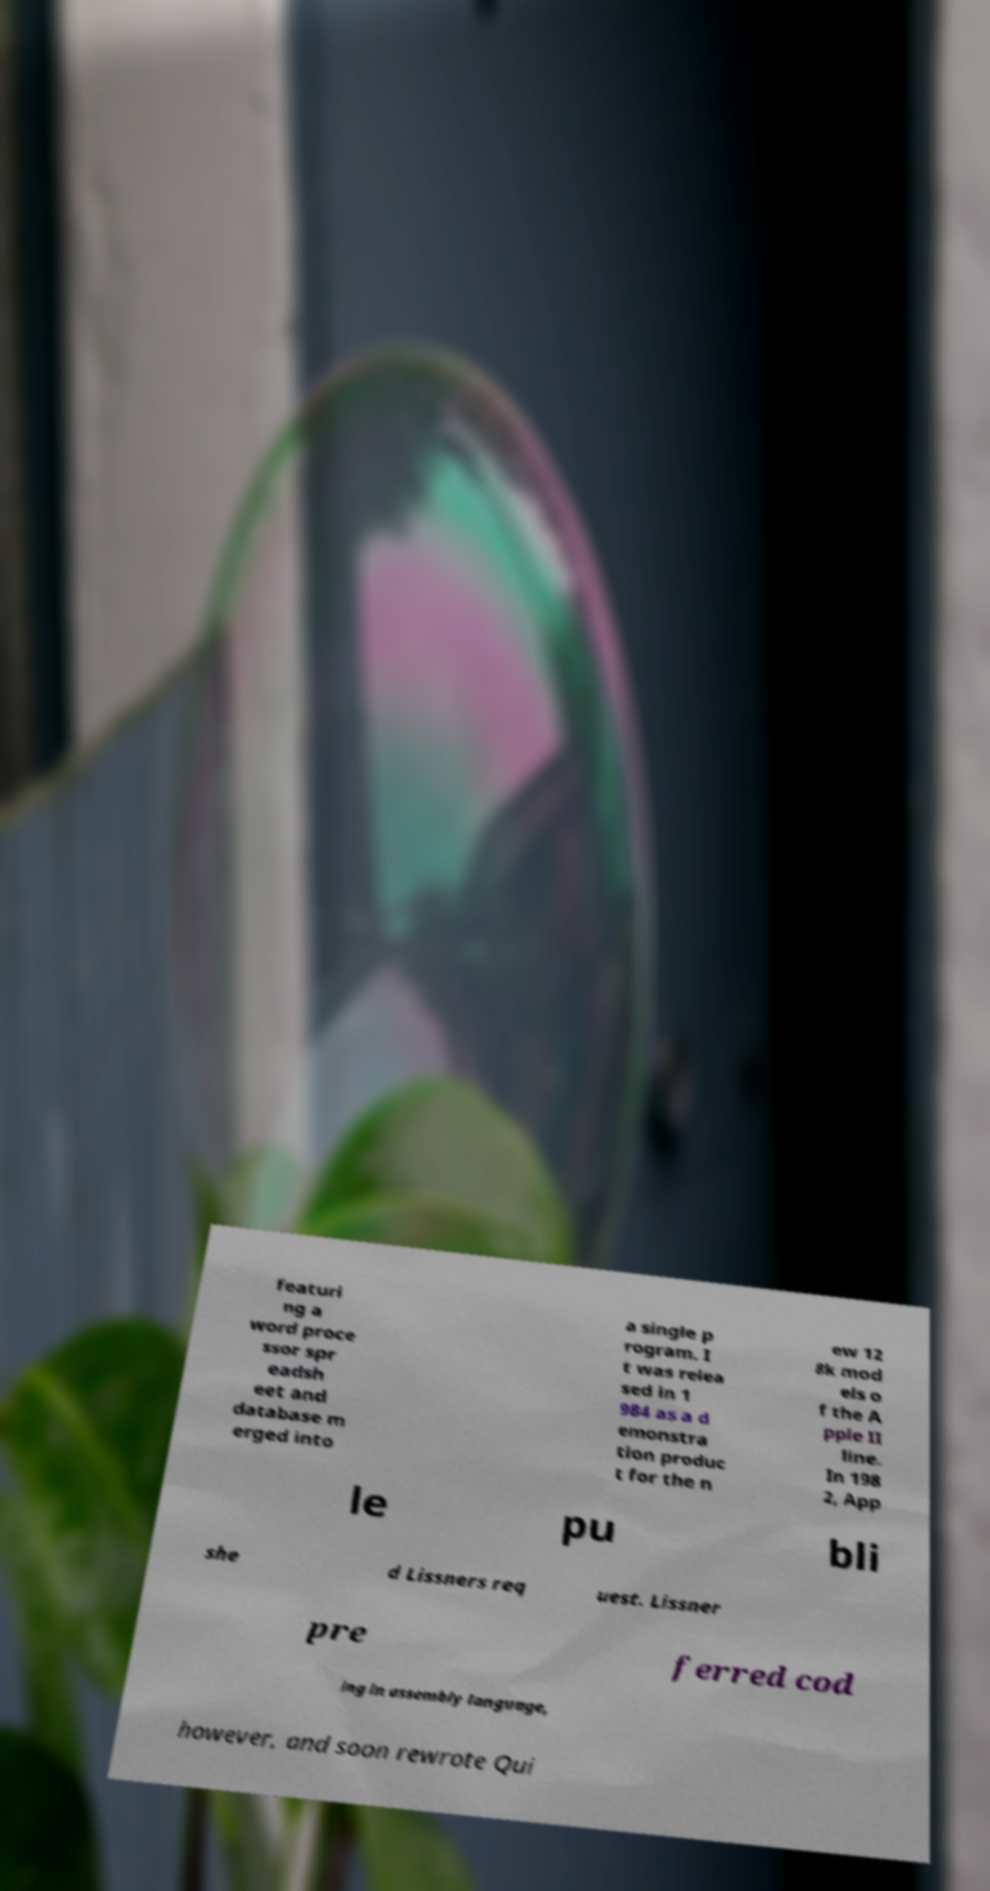I need the written content from this picture converted into text. Can you do that? featuri ng a word proce ssor spr eadsh eet and database m erged into a single p rogram. I t was relea sed in 1 984 as a d emonstra tion produc t for the n ew 12 8k mod els o f the A pple II line. In 198 2, App le pu bli she d Lissners req uest. Lissner pre ferred cod ing in assembly language, however, and soon rewrote Qui 